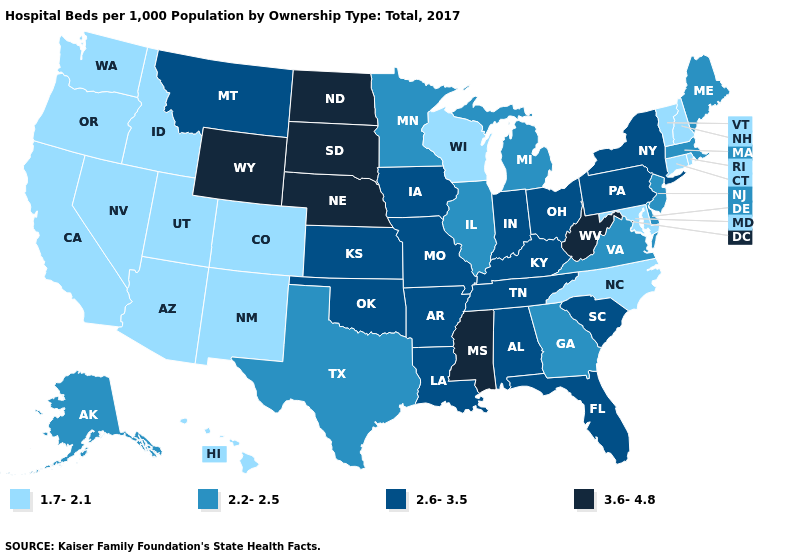Among the states that border Kansas , does Colorado have the lowest value?
Write a very short answer. Yes. Does Texas have a higher value than North Carolina?
Short answer required. Yes. What is the value of New Hampshire?
Write a very short answer. 1.7-2.1. Name the states that have a value in the range 1.7-2.1?
Write a very short answer. Arizona, California, Colorado, Connecticut, Hawaii, Idaho, Maryland, Nevada, New Hampshire, New Mexico, North Carolina, Oregon, Rhode Island, Utah, Vermont, Washington, Wisconsin. Among the states that border Wisconsin , which have the highest value?
Keep it brief. Iowa. Name the states that have a value in the range 3.6-4.8?
Write a very short answer. Mississippi, Nebraska, North Dakota, South Dakota, West Virginia, Wyoming. Among the states that border Vermont , does New Hampshire have the highest value?
Write a very short answer. No. Name the states that have a value in the range 3.6-4.8?
Be succinct. Mississippi, Nebraska, North Dakota, South Dakota, West Virginia, Wyoming. Name the states that have a value in the range 3.6-4.8?
Give a very brief answer. Mississippi, Nebraska, North Dakota, South Dakota, West Virginia, Wyoming. What is the value of Arkansas?
Concise answer only. 2.6-3.5. Name the states that have a value in the range 3.6-4.8?
Quick response, please. Mississippi, Nebraska, North Dakota, South Dakota, West Virginia, Wyoming. What is the value of New Jersey?
Concise answer only. 2.2-2.5. Name the states that have a value in the range 3.6-4.8?
Write a very short answer. Mississippi, Nebraska, North Dakota, South Dakota, West Virginia, Wyoming. What is the highest value in the USA?
Write a very short answer. 3.6-4.8. Name the states that have a value in the range 1.7-2.1?
Keep it brief. Arizona, California, Colorado, Connecticut, Hawaii, Idaho, Maryland, Nevada, New Hampshire, New Mexico, North Carolina, Oregon, Rhode Island, Utah, Vermont, Washington, Wisconsin. 